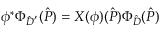Convert formula to latex. <formula><loc_0><loc_0><loc_500><loc_500>\phi ^ { * } \Phi _ { \hat { D } ^ { ^ { \prime } } } ( \hat { P } ) = X ( \phi ) ( \hat { P } ) \Phi _ { \hat { D } } ( \hat { P } )</formula> 